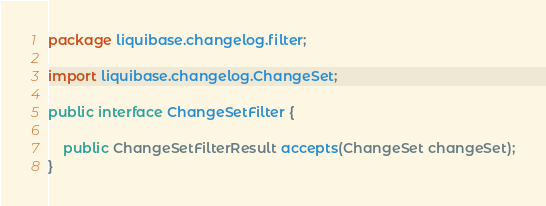Convert code to text. <code><loc_0><loc_0><loc_500><loc_500><_Java_>package liquibase.changelog.filter;

import liquibase.changelog.ChangeSet;

public interface ChangeSetFilter {

    public ChangeSetFilterResult accepts(ChangeSet changeSet);
}
</code> 